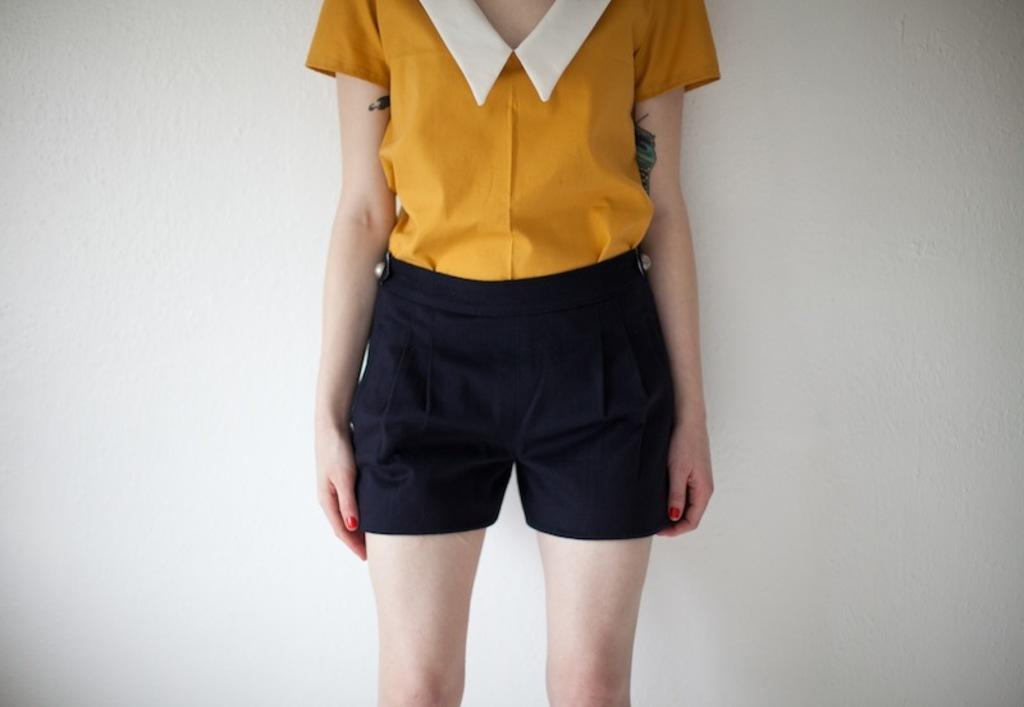What is the main subject of the image? There is a person in the image. What is the person wearing on their upper body? The person is wearing a yellow shirt. What is the person wearing on their lower body? The person is wearing black shorts. What is the person's posture in the image? The person is standing. What type of soup is the person eating in the image? There is no soup present in the image; the person is wearing a yellow shirt and black shorts while standing. 